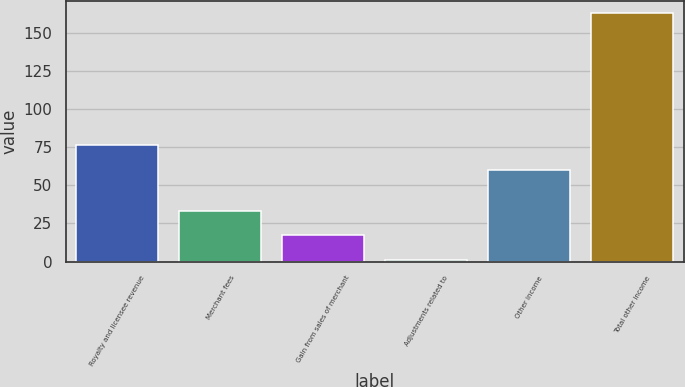Convert chart. <chart><loc_0><loc_0><loc_500><loc_500><bar_chart><fcel>Royalty and licensee revenue<fcel>Merchant fees<fcel>Gain from sales of merchant<fcel>Adjustments related to<fcel>Other income<fcel>Total other income<nl><fcel>76.2<fcel>33.4<fcel>17.2<fcel>1<fcel>60<fcel>163<nl></chart> 